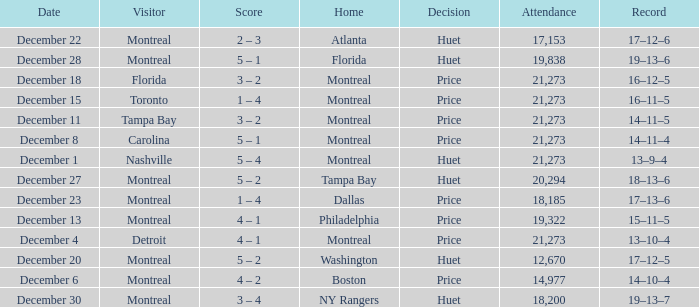What is the score when Philadelphia is at home? 4 – 1. 